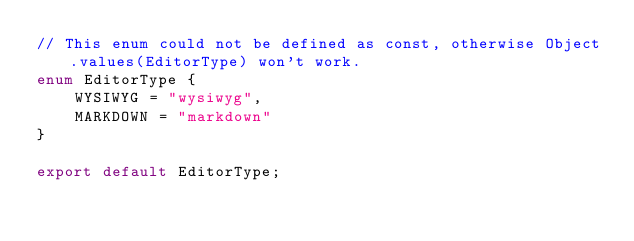Convert code to text. <code><loc_0><loc_0><loc_500><loc_500><_TypeScript_>// This enum could not be defined as const, otherwise Object.values(EditorType) won't work.
enum EditorType {
    WYSIWYG = "wysiwyg",
    MARKDOWN = "markdown"
}

export default EditorType;
</code> 